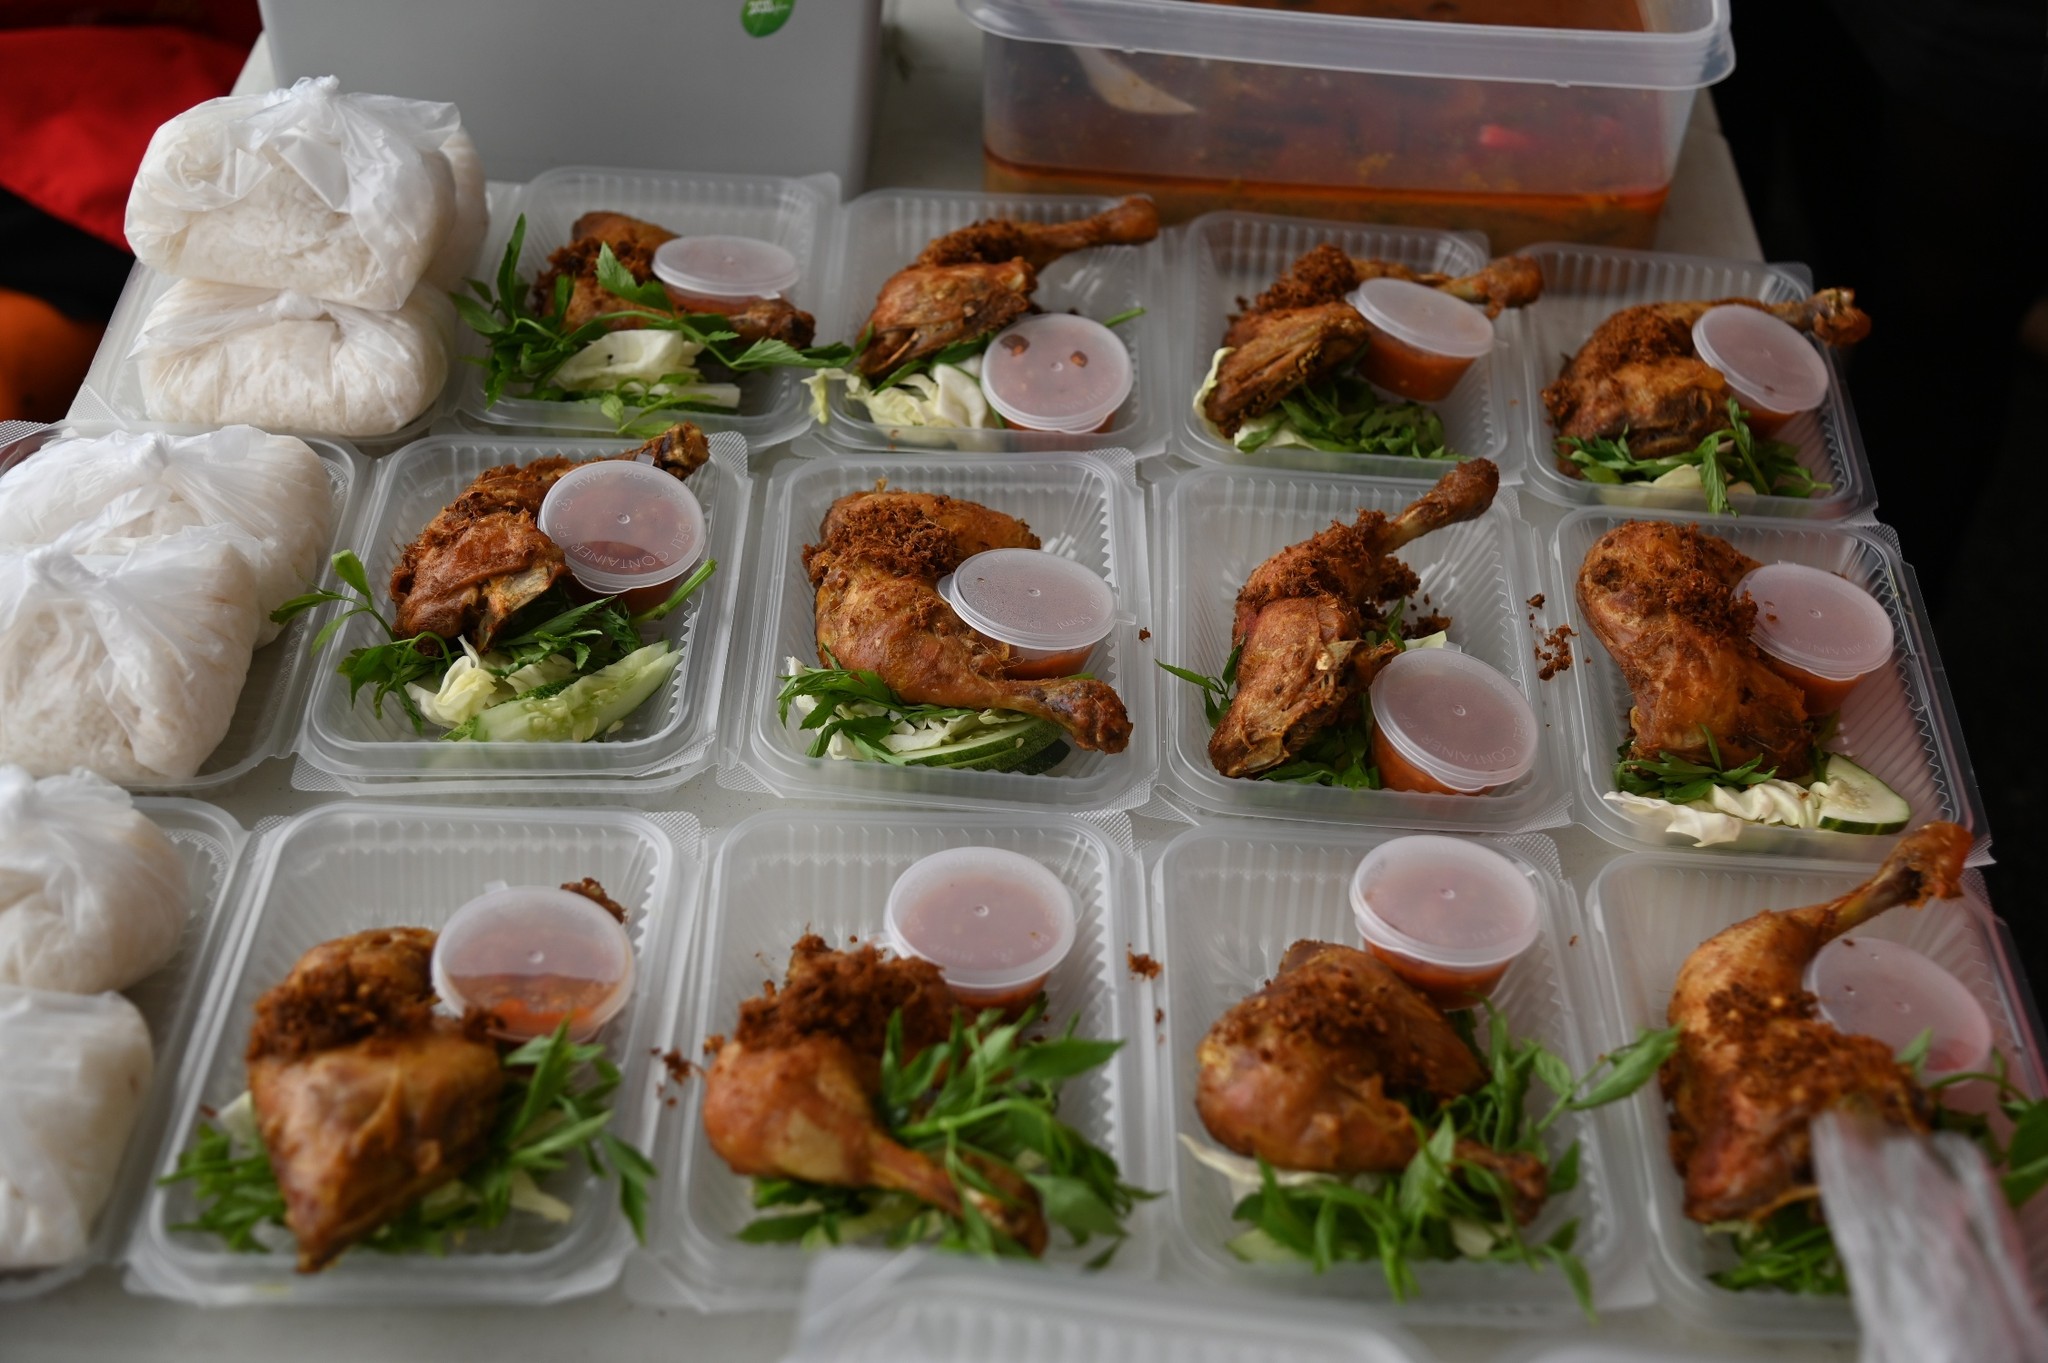Analyze the image in a comprehensive and detailed manner.
 The image captures a scene of meal preparation, with a focus on a table covered in a black tablecloth. The table is neatly organized with 12 clear plastic containers, each containing a meal. The containers are arranged in a grid of 3 rows and 4 columns. 

Each container holds a piece of fried chicken, a portion of greens, and a small cup of sauce. The fried chicken appears to be golden-brown, indicating it might be breaded and deep-fried. The greens add a touch of vibrant color to the meal. The small cup of sauce is placed beside the chicken, ready to add flavor as needed.

On the left side of the table, there are 2 bags of white rice. The rice is presumably a side dish to accompany the chicken and greens. On the right side of the table, there's a large orange container that holds additional pieces of fried chicken, suggesting that more meals are yet to be prepared.

Overall, the image depicts a well-organized meal prep scenario, with a focus on portion control and balanced nutrition. 